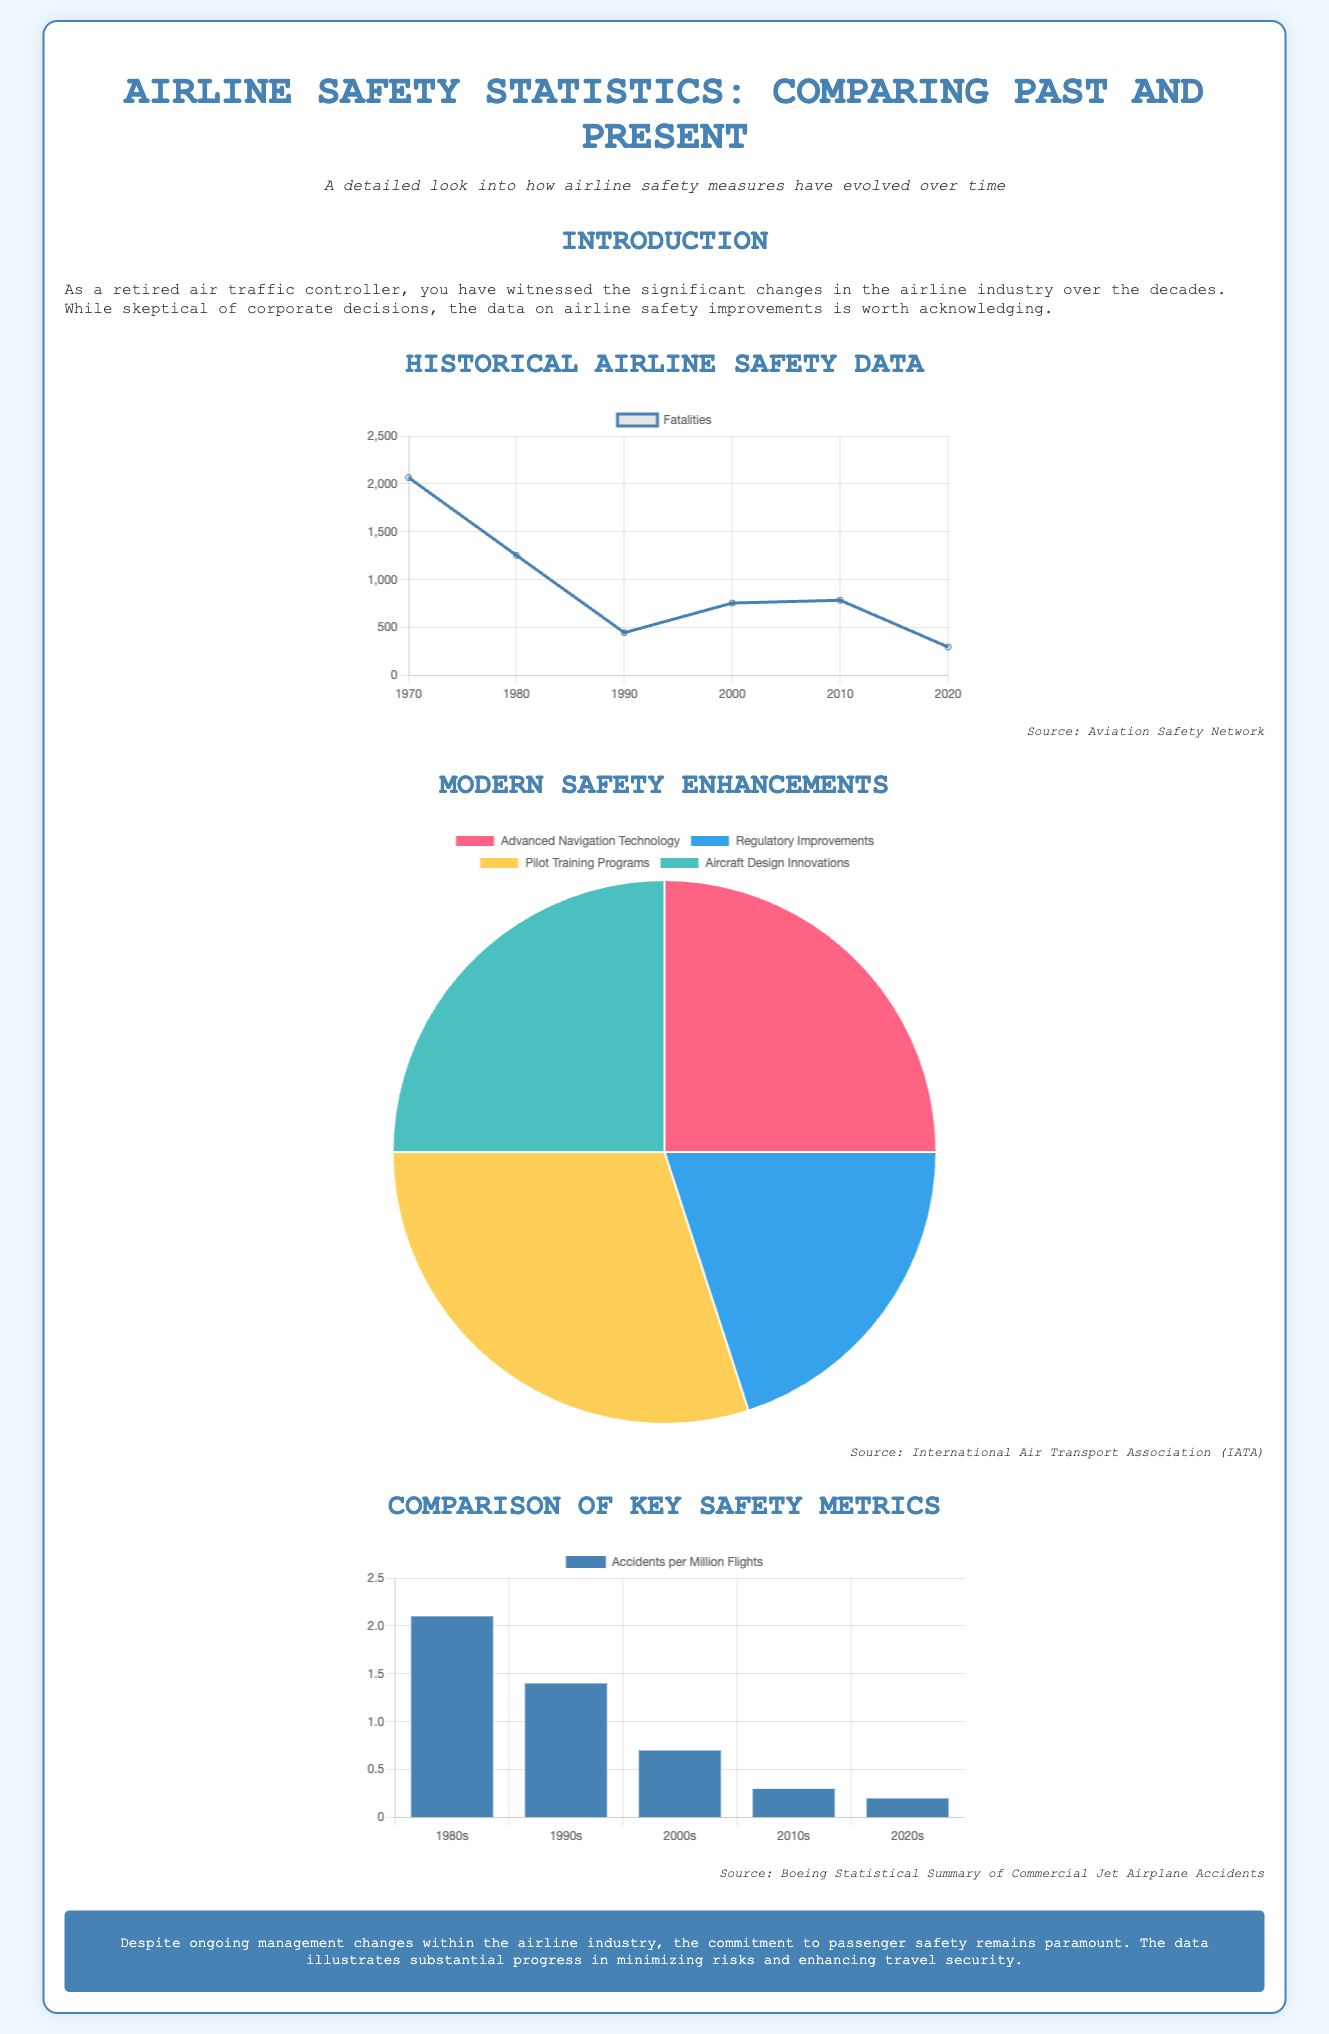What was the number of fatalities in 2000? The chart for fatalities shows that there were 757 fatalities in the year 2000.
Answer: 757 What year had the highest number of fatalities? In the historical data, the highest number of fatalities occurred in 1970, with 2067 fatalities.
Answer: 1970 What percentage does Pilot Training Programs contribute to airline safety? The pie chart indicates that Pilot Training Programs account for 30% of the contributors to airline safety.
Answer: 30% Which decade saw the lowest accidents per million flights? The accidents chart indicates that the 2020s had the lowest figure of 0.2 accidents per million flights.
Answer: 2020s What was the number of fatalities in 2020? The data for fatalities states that there were 298 fatalities in the year 2020.
Answer: 298 What are the categories included in the Safety Contributors Chart? The safety contributors are Advanced Navigation Technology, Regulatory Improvements, Pilot Training Programs, and Aircraft Design Innovations.
Answer: Advanced Navigation Technology, Regulatory Improvements, Pilot Training Programs, Aircraft Design Innovations What is the title of the document? The title of the document is "Airline Safety Statistics: Comparing Past and Present."
Answer: Airline Safety Statistics: Comparing Past and Present What was the fatalities count in 1990? According to the fatalities chart, the count of fatalities in 1990 was 448.
Answer: 448 What color represents Regulatory Improvements in the Safety Contributors Chart? Regulatory Improvements is represented by the color blue in the pie chart.
Answer: Blue 